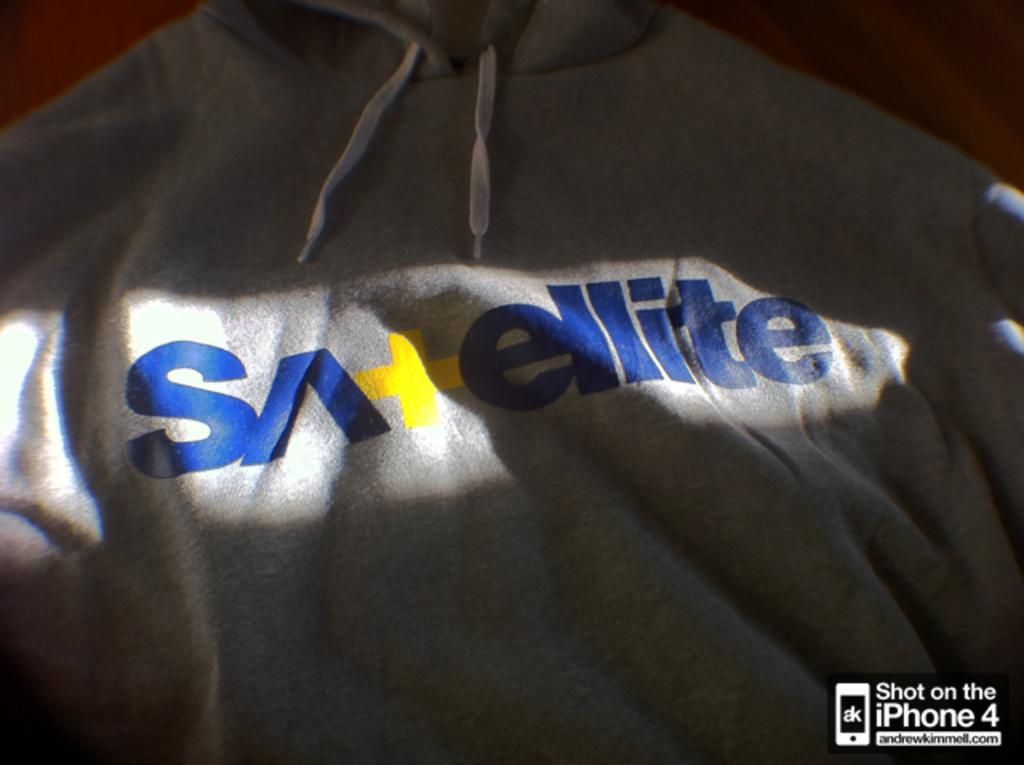<image>
Describe the image concisely. Sweater with words in blue that says Satellite. 